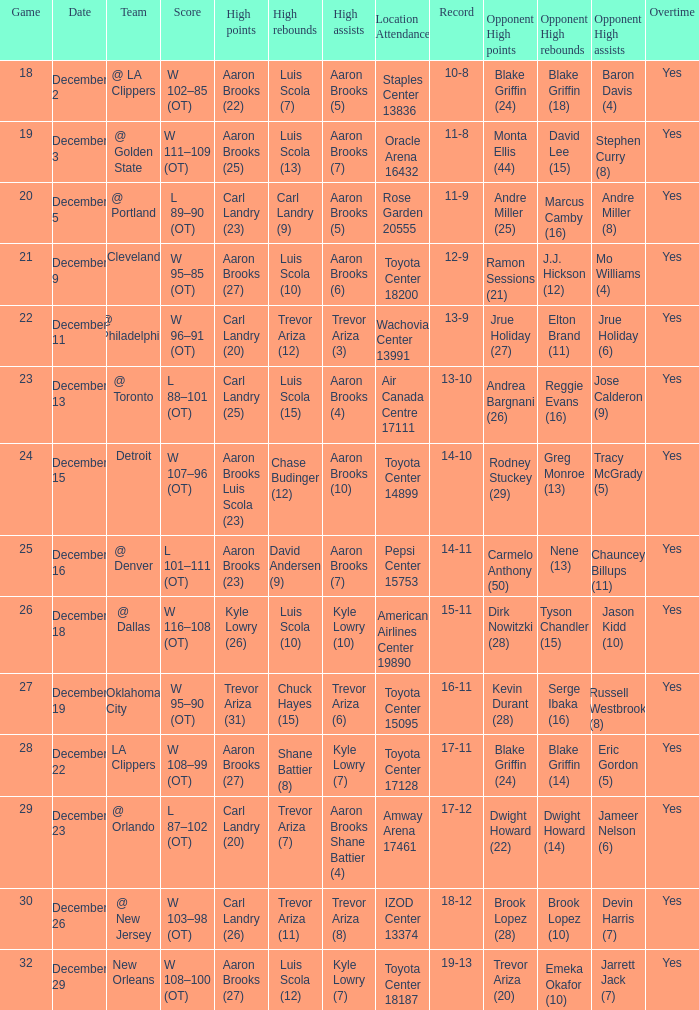What's the end score of the game where Shane Battier (8) did the high rebounds? W 108–99 (OT). 